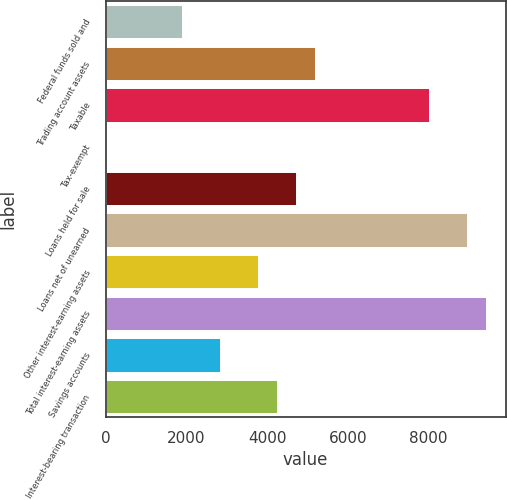Convert chart. <chart><loc_0><loc_0><loc_500><loc_500><bar_chart><fcel>Federal funds sold and<fcel>Trading account assets<fcel>Taxable<fcel>Tax-exempt<fcel>Loans held for sale<fcel>Loans net of unearned<fcel>Other interest-earning assets<fcel>Total interest-earning assets<fcel>Savings accounts<fcel>Interest-bearing transaction<nl><fcel>1889<fcel>5193<fcel>8025<fcel>1<fcel>4721<fcel>8969<fcel>3777<fcel>9441<fcel>2833<fcel>4249<nl></chart> 